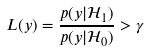Convert formula to latex. <formula><loc_0><loc_0><loc_500><loc_500>L ( y ) = \frac { p ( y | \mathcal { H } _ { 1 } ) } { p ( y | \mathcal { H } _ { 0 } ) } > \gamma</formula> 